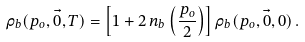<formula> <loc_0><loc_0><loc_500><loc_500>\rho _ { b } ( p _ { o } , \vec { 0 } , T ) = \left [ 1 + 2 \, n _ { b } \left ( \frac { p _ { o } } { 2 } \right ) \right ] \rho _ { b } ( p _ { o } , \vec { 0 } , 0 ) \, .</formula> 